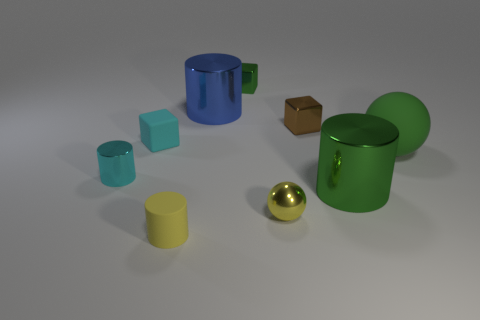Do the green shiny thing that is behind the large green metal object and the cyan matte thing on the left side of the big green rubber object have the same shape?
Offer a very short reply. Yes. How many rubber things are small blocks or green cubes?
Your response must be concise. 1. What material is the small ball that is the same color as the matte cylinder?
Offer a very short reply. Metal. There is a big cylinder that is on the right side of the green block; what is its material?
Give a very brief answer. Metal. Is the material of the cylinder that is behind the green matte object the same as the tiny cyan block?
Ensure brevity in your answer.  No. What number of things are either tiny green things or small things in front of the large green metallic thing?
Keep it short and to the point. 3. The yellow thing that is the same shape as the cyan metallic thing is what size?
Offer a very short reply. Small. Are there any green rubber objects left of the small brown cube?
Offer a very short reply. No. Does the big metallic cylinder that is to the right of the tiny metallic sphere have the same color as the sphere that is on the right side of the green shiny cylinder?
Offer a terse response. Yes. Is there another small object of the same shape as the brown metallic object?
Ensure brevity in your answer.  Yes. 